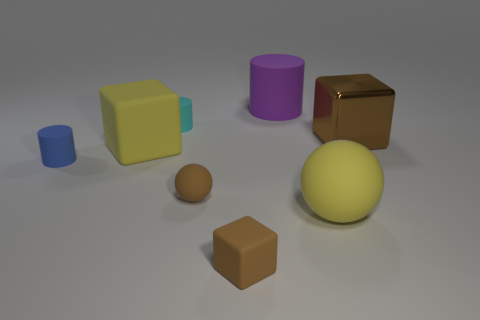Is there a green shiny sphere that has the same size as the cyan cylinder?
Provide a succinct answer. No. There is a cylinder to the right of the small brown block; is there a brown cube left of it?
Give a very brief answer. Yes. What number of blocks are brown matte objects or shiny objects?
Provide a short and direct response. 2. Is there another cyan object that has the same shape as the cyan thing?
Ensure brevity in your answer.  No. There is a tiny cyan thing; what shape is it?
Your answer should be very brief. Cylinder. How many things are big green things or small brown matte blocks?
Provide a short and direct response. 1. There is a yellow rubber object behind the blue matte thing; does it have the same size as the yellow matte thing that is in front of the blue cylinder?
Provide a succinct answer. Yes. How many other objects are there of the same material as the purple cylinder?
Provide a succinct answer. 6. Are there more yellow rubber cubes that are behind the purple rubber object than rubber spheres to the right of the tiny blue cylinder?
Ensure brevity in your answer.  No. There is a big yellow thing that is to the left of the small cyan object; what is it made of?
Your response must be concise. Rubber. 